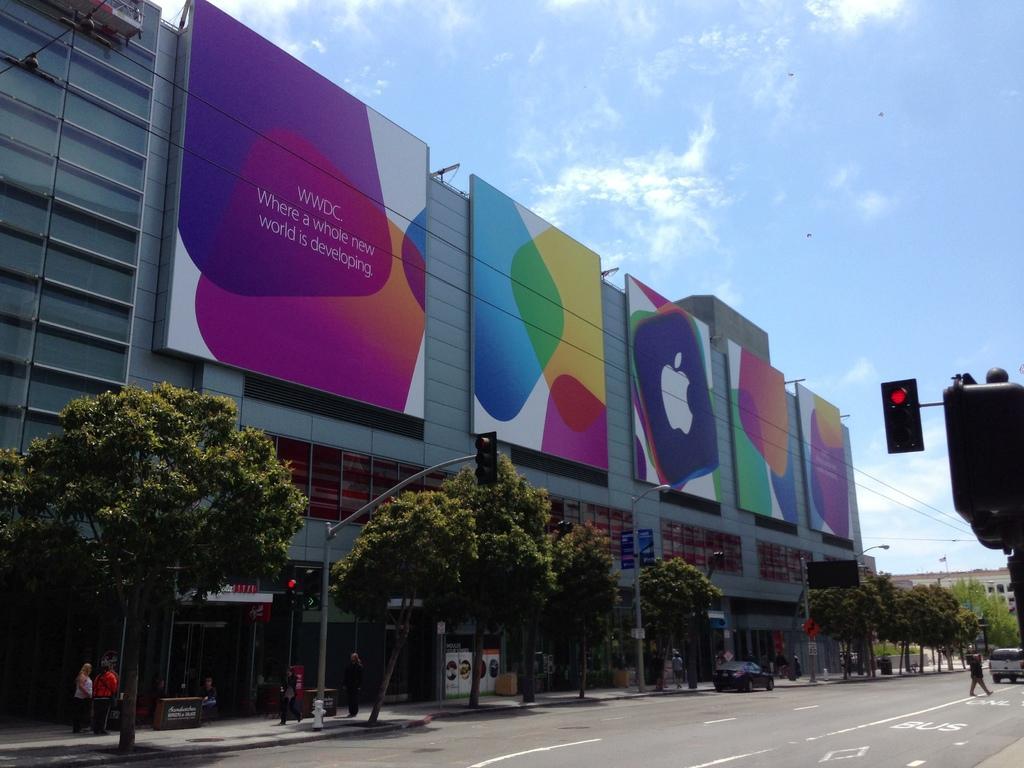How would you summarize this image in a sentence or two? This image consists of many people. In the front, we can see many trees and few people. At the bottom, there is a road. In the background, we can see a building on which there are hoardings. At the top, there are clouds in the sky. On the right, we can see a signal light. 